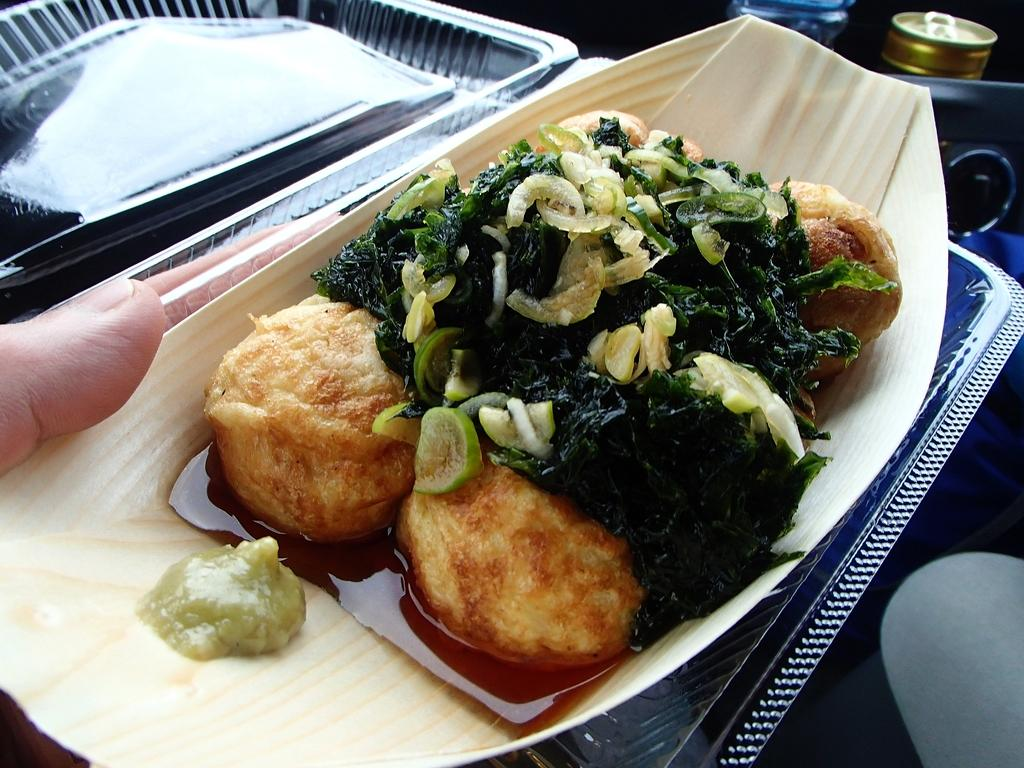What is the main subject of the image? There is a person in the image. What is the person holding in the image? The person is holding a food item in a box. Can you describe the objects in the top right corner of the image? Unfortunately, the provided facts do not mention any objects in the top right corner of the image. What type of stone is being used as a property marker in the image? There is no stone or property marker present in the image. Is the person in the image currently in jail? There is no indication in the image that the person is in jail. 